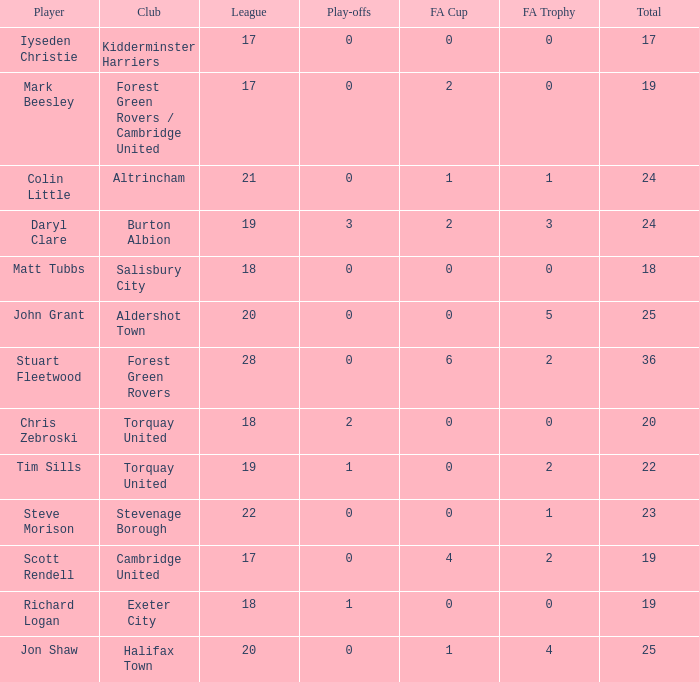What mean total had a league number of 18, Richard Logan as a player, and a play-offs number smaller than 1? None. 